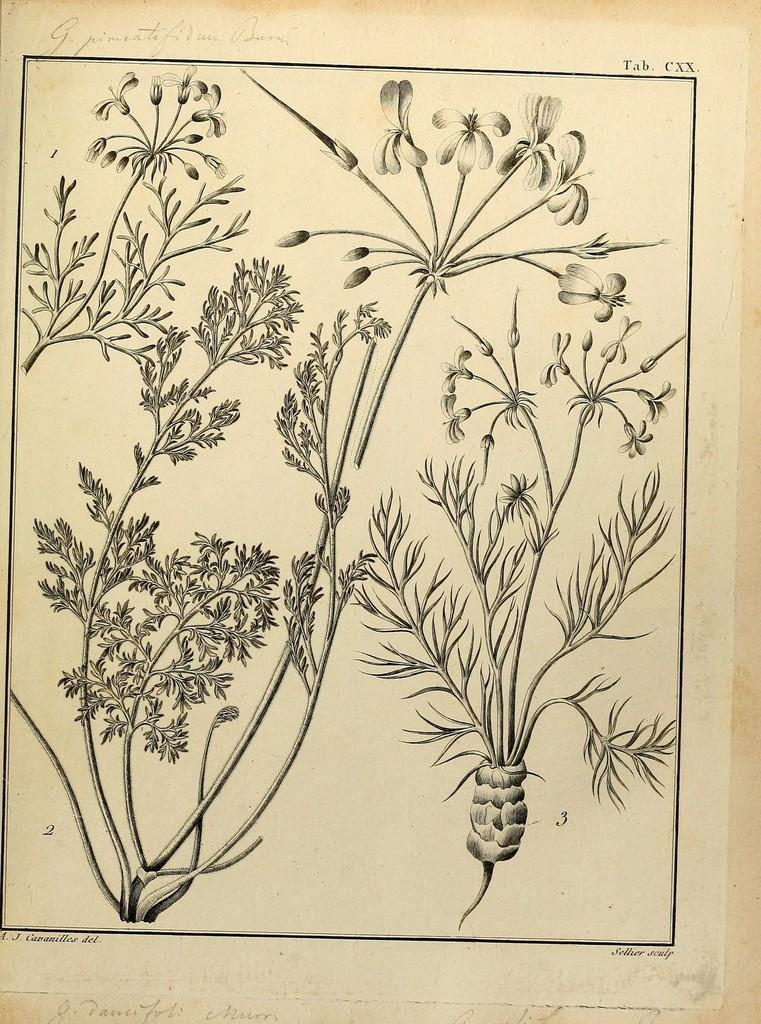What is the main subject of the paper in the image? The main subject of the paper in the image is plants and leaves. What type of diagrams are included on the paper? The paper contains diagrams of plants and leaves. What is the content of the text on the paper? The text on the paper is about plants and leaves. What hobbies does the yam have in the image? There is no yam present in the image, so it is not possible to determine any hobbies. 